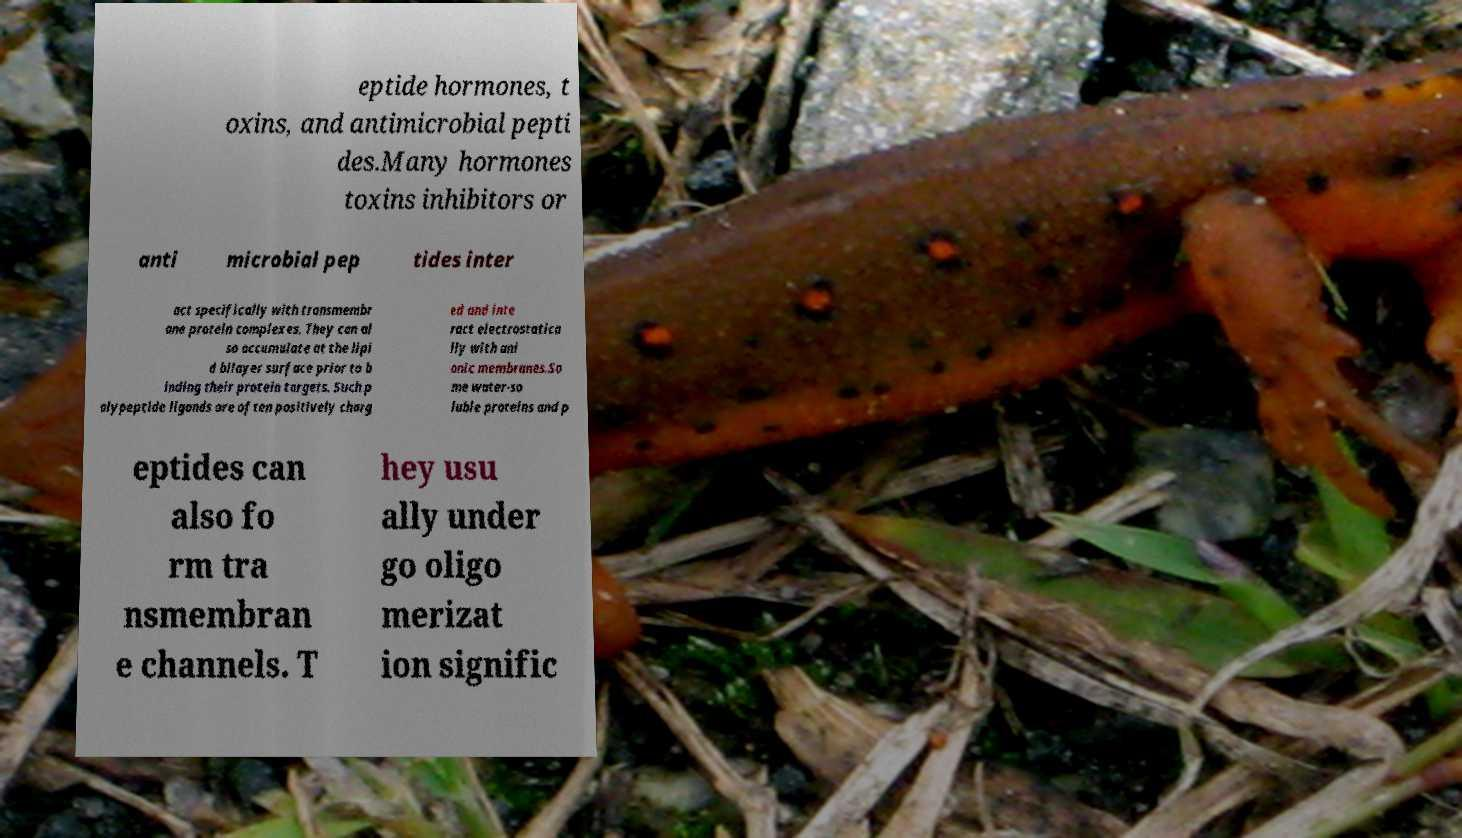Could you assist in decoding the text presented in this image and type it out clearly? eptide hormones, t oxins, and antimicrobial pepti des.Many hormones toxins inhibitors or anti microbial pep tides inter act specifically with transmembr ane protein complexes. They can al so accumulate at the lipi d bilayer surface prior to b inding their protein targets. Such p olypeptide ligands are often positively charg ed and inte ract electrostatica lly with ani onic membranes.So me water-so luble proteins and p eptides can also fo rm tra nsmembran e channels. T hey usu ally under go oligo merizat ion signific 